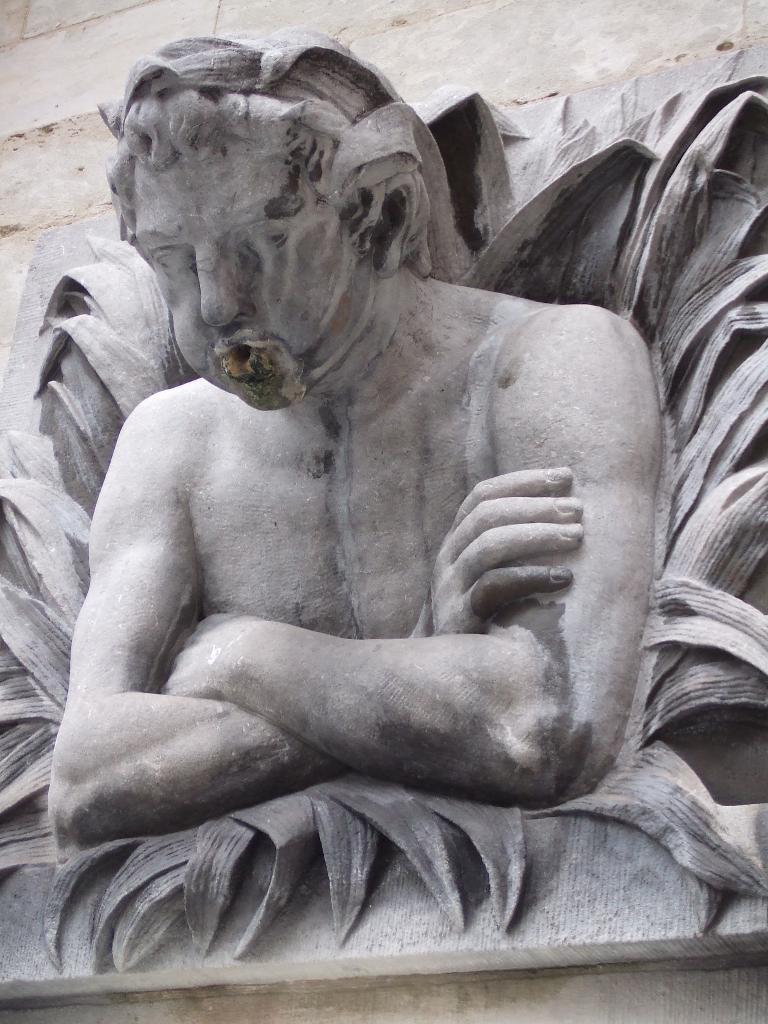Please provide a concise description of this image. In the picture I can see a sculpture of a person and there are some other objects in the background. 